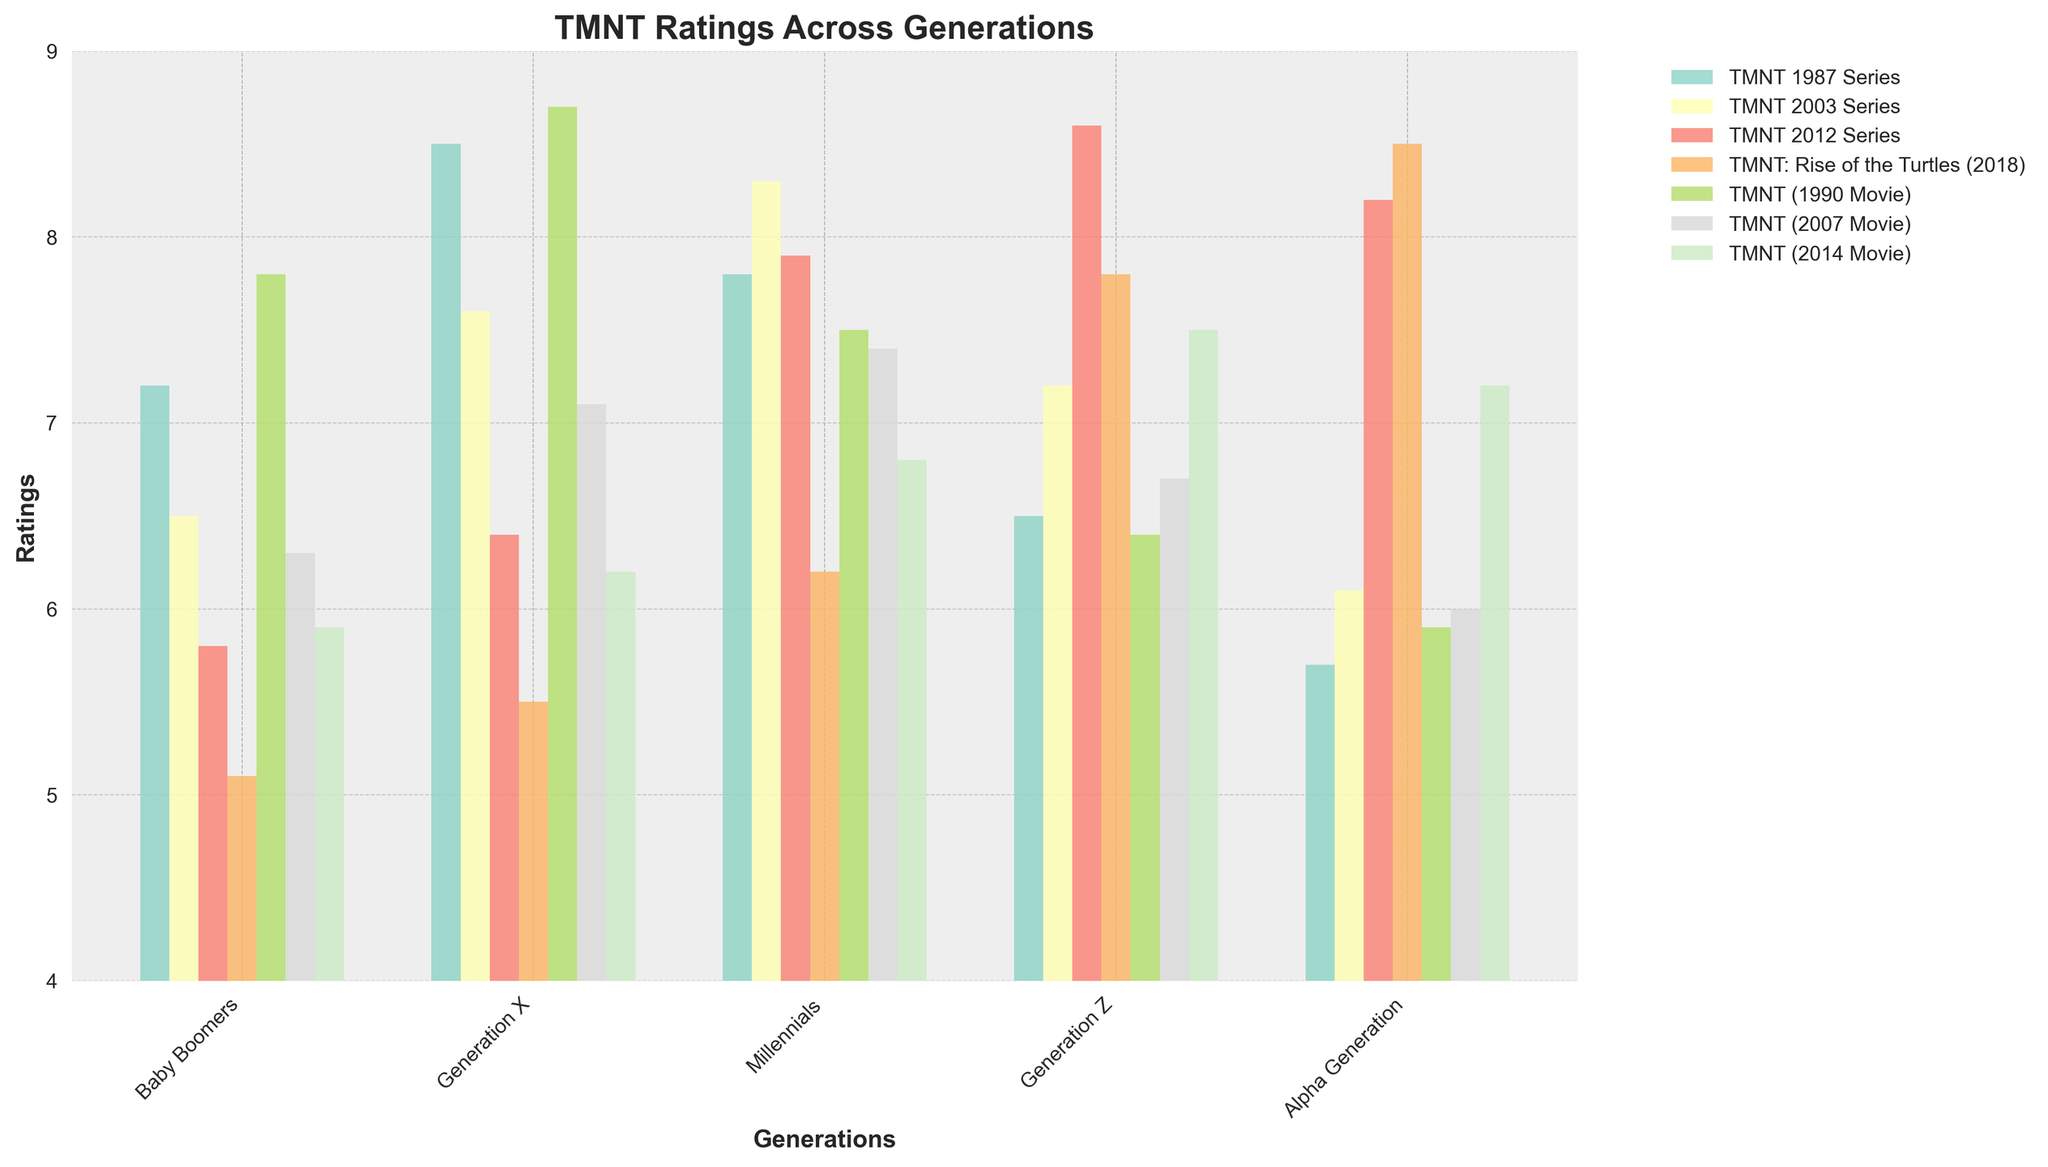What generation rated the 'TMNT 1990 Movie' the highest? To find which generation rated the 'TMNT 1990 Movie' the highest, one should compare the bars for the 'TMNT 1990 Movie' across all generations. The highest rating appears in Generation X, which is 8.7.
Answer: Generation X Which series has the most even ratings across generations? To determine which series has the most even ratings across generations, look at the heights of the series bars across generations. The 'TMNT 2003 Series' has ratings of 6.5, 7.6, 8.3, 7.2, and 6.1 among the generations respectively, which are relatively close to each other compared to other series.
Answer: TMNT 2003 Series Compare the ratings of 'TMNT: Rise of the Turtles (2018)' between Generation Z and Alpha Generation. Which is higher? To compare the ratings, look at the bars representing 'TMNT: Rise of the Turtles (2018)' for Generation Z and Alpha Generation. Generation Z rated it 7.8, while Alpha Generation rated it 8.5.
Answer: Alpha Generation What is the average rating of 'TMNT 2012 Series' across all generations? To find the average rating of the 'TMNT 2012 Series', add the ratings for all generations and divide by the number of generations: (5.8 + 6.4 + 7.9 + 8.6 + 8.2)/5. This equals 36.9/5 = 7.4.
Answer: 7.4 Which generation rated the 'TMNT (2014 Movie)' the lowest? Compare the bars for the 'TMNT (2014 Movie)' across all generations. The lowest rating is 5.9 from Baby Boomers.
Answer: Baby Boomers What is the difference in ratings between 'TMNT 1987 Series’ and ‘TMNT 2012 Series’ for Millennials? Find the ratings of 'TMNT 1987 Series’ and ‘TMNT 2012 Series’ for Millennials and calculate their difference. The rating for 'TMNT 1987 Series' is 7.8 and for 'TMNT 2012 Series' is 7.9. The difference is 7.9 - 7.8 = 0.1.
Answer: 0.1 Which series or movie has a consistently increasing rating from Baby Boomers to Alpha Generation? To find the series or movie with consistently increasing ratings, look at the height of the bars for each series or movie. 'TMNT: Rise of the Turtles (2018)' shows consistently increasing ratings: 5.1, 5.5, 6.2, 7.8, 8.5.
Answer: TMNT: Rise of the Turtles (2018) For which generation is the 'TMNT 1987 Series' the highest-rated series among all the series and movies? For each generation, check if 'TMNT 1987 Series' has the highest bar among all series and movies. For Generation X, the 'TMNT 1987 Series' has the highest rating among all series and movies at 8.5.
Answer: Generation X 